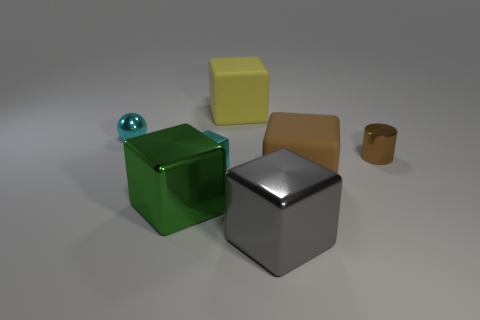Subtract all gray cubes. How many cubes are left? 4 Subtract all small cubes. How many cubes are left? 4 Subtract all red blocks. Subtract all brown cylinders. How many blocks are left? 5 Add 1 tiny shiny things. How many objects exist? 8 Subtract all cubes. How many objects are left? 2 Subtract 1 brown cylinders. How many objects are left? 6 Subtract all large blue shiny things. Subtract all big gray metallic cubes. How many objects are left? 6 Add 3 gray metal things. How many gray metal things are left? 4 Add 2 small gray metallic blocks. How many small gray metallic blocks exist? 2 